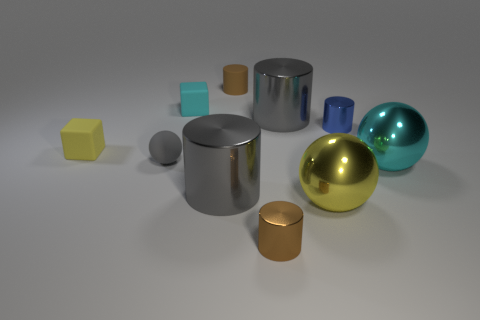Is there any other thing that is the same shape as the small brown shiny thing?
Your answer should be compact. Yes. What number of things are in front of the big yellow metallic ball?
Provide a short and direct response. 1. Are there the same number of small spheres that are right of the cyan sphere and red spheres?
Give a very brief answer. Yes. Does the tiny cyan block have the same material as the small gray object?
Provide a succinct answer. Yes. There is a shiny object that is behind the yellow block and to the left of the blue metallic cylinder; how big is it?
Make the answer very short. Large. What number of cyan metallic balls are the same size as the brown rubber thing?
Your answer should be compact. 0. What is the size of the brown object that is behind the large gray cylinder right of the brown matte cylinder?
Provide a succinct answer. Small. There is a yellow object on the left side of the cyan matte thing; does it have the same shape as the large gray metallic object that is in front of the blue metal object?
Provide a short and direct response. No. There is a metal thing that is to the left of the tiny blue cylinder and behind the tiny gray rubber sphere; what is its color?
Your response must be concise. Gray. Are there any metallic cubes of the same color as the small sphere?
Give a very brief answer. No. 